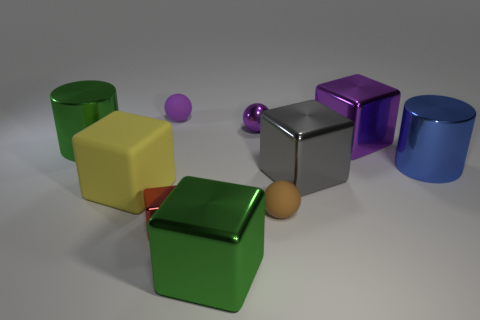What material is the large object that is the same color as the metallic sphere?
Your response must be concise. Metal. There is a matte object that is behind the big cylinder that is on the right side of the gray cube; what is its size?
Provide a succinct answer. Small. There is a big green thing in front of the gray thing; is it the same shape as the matte thing on the left side of the tiny purple rubber thing?
Provide a short and direct response. Yes. The large metallic thing that is both behind the gray shiny block and on the left side of the gray metallic block is what color?
Ensure brevity in your answer.  Green. Is there a small object of the same color as the metallic sphere?
Keep it short and to the point. Yes. There is a sphere that is in front of the purple shiny block; what color is it?
Your answer should be very brief. Brown. There is a matte object that is to the right of the tiny red cube; is there a metallic cylinder that is right of it?
Make the answer very short. Yes. Does the shiny ball have the same color as the small matte object that is behind the purple cube?
Offer a very short reply. Yes. Is there a tiny cylinder that has the same material as the small cube?
Offer a very short reply. No. What number of tiny cyan rubber cylinders are there?
Provide a succinct answer. 0. 